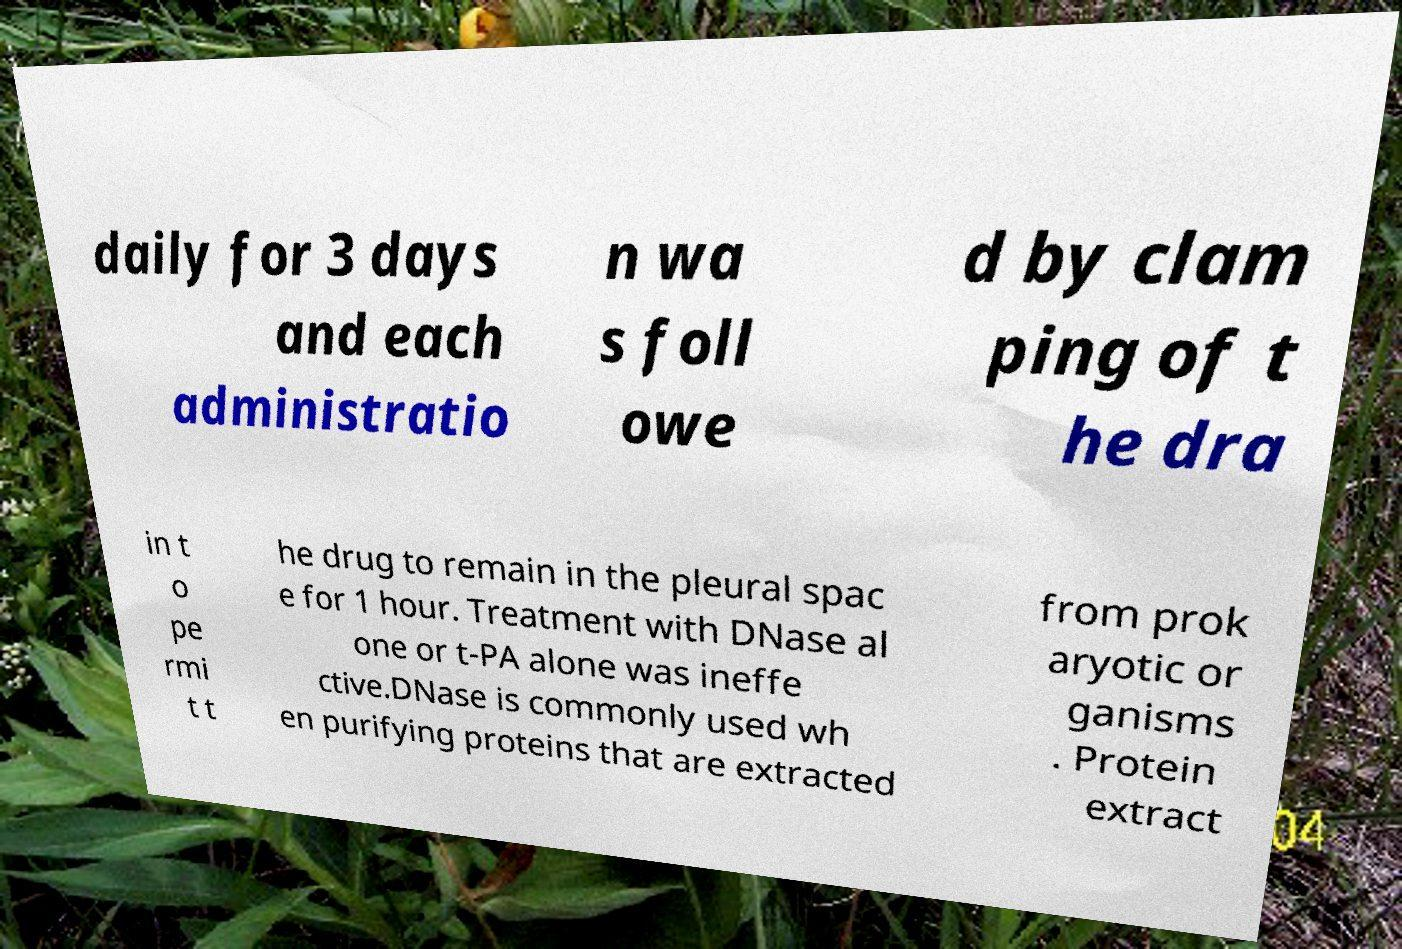Can you read and provide the text displayed in the image?This photo seems to have some interesting text. Can you extract and type it out for me? daily for 3 days and each administratio n wa s foll owe d by clam ping of t he dra in t o pe rmi t t he drug to remain in the pleural spac e for 1 hour. Treatment with DNase al one or t-PA alone was ineffe ctive.DNase is commonly used wh en purifying proteins that are extracted from prok aryotic or ganisms . Protein extract 